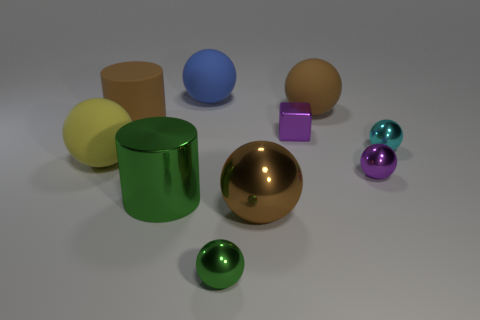How does the lighting affect the appearance of these objects? The lighting in the image creates soft shadows and highlights, which suggest that the scene is illuminated with a diffused light source. This type of lighting enhances the three-dimensionality of the objects and accentuates the reflective properties of the metallic surfaces, while also allowing for the colors of the matte objects to appear vivid without producing harsh glares. 